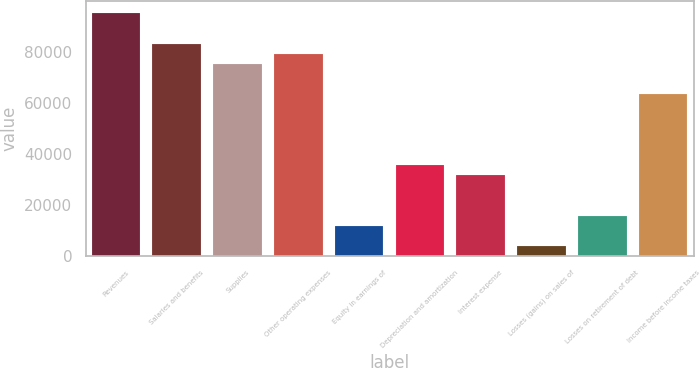Convert chart. <chart><loc_0><loc_0><loc_500><loc_500><bar_chart><fcel>Revenues<fcel>Salaries and benefits<fcel>Supplies<fcel>Other operating expenses<fcel>Equity in earnings of<fcel>Depreciation and amortization<fcel>Interest expense<fcel>Losses (gains) on sales of<fcel>Losses on retirement of debt<fcel>Income before income taxes<nl><fcel>95220.2<fcel>83318.3<fcel>75383.7<fcel>79351<fcel>11906.9<fcel>35710.7<fcel>31743.4<fcel>3972.29<fcel>15874.2<fcel>63481.8<nl></chart> 